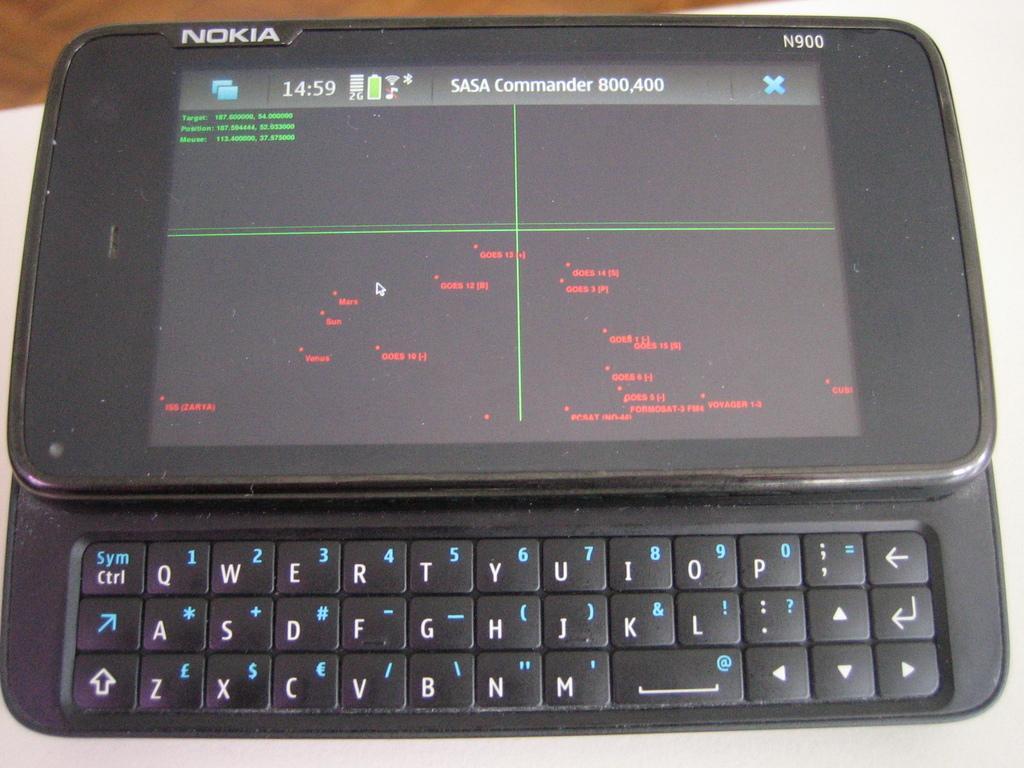Can you describe this image briefly? In the picture I can see a mobile phone on which we can see something is displayed and here we can see the keypad. This is placed on the white color surface. 